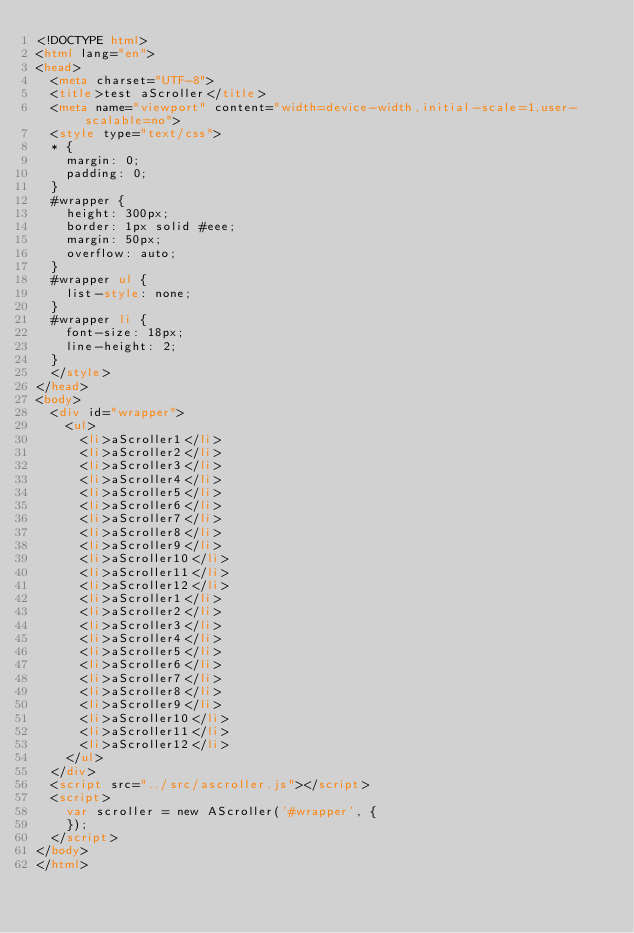<code> <loc_0><loc_0><loc_500><loc_500><_HTML_><!DOCTYPE html>
<html lang="en">
<head>
  <meta charset="UTF-8">
  <title>test aScroller</title>
  <meta name="viewport" content="width=device-width,initial-scale=1,user-scalable=no">
  <style type="text/css">
  * {
    margin: 0;
    padding: 0;
  }
  #wrapper {
    height: 300px;
    border: 1px solid #eee;
    margin: 50px;
    overflow: auto;
  }
  #wrapper ul {
    list-style: none;
  }
  #wrapper li {
    font-size: 18px;
    line-height: 2;
  }
  </style>
</head>
<body>
  <div id="wrapper">
    <ul>
      <li>aScroller1</li>
      <li>aScroller2</li>
      <li>aScroller3</li>
      <li>aScroller4</li>
      <li>aScroller5</li>
      <li>aScroller6</li>
      <li>aScroller7</li>
      <li>aScroller8</li>
      <li>aScroller9</li>
      <li>aScroller10</li>
      <li>aScroller11</li>
      <li>aScroller12</li>
      <li>aScroller1</li>
      <li>aScroller2</li>
      <li>aScroller3</li>
      <li>aScroller4</li>
      <li>aScroller5</li>
      <li>aScroller6</li>
      <li>aScroller7</li>
      <li>aScroller8</li>
      <li>aScroller9</li>
      <li>aScroller10</li>
      <li>aScroller11</li>
      <li>aScroller12</li>
    </ul>
  </div>
  <script src="../src/ascroller.js"></script>
  <script>
    var scroller = new AScroller('#wrapper', {
    });
  </script>
</body>
</html></code> 